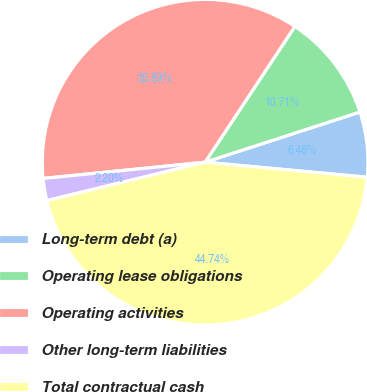Convert chart to OTSL. <chart><loc_0><loc_0><loc_500><loc_500><pie_chart><fcel>Long-term debt (a)<fcel>Operating lease obligations<fcel>Operating activities<fcel>Other long-term liabilities<fcel>Total contractual cash<nl><fcel>6.46%<fcel>10.71%<fcel>35.89%<fcel>2.2%<fcel>44.74%<nl></chart> 